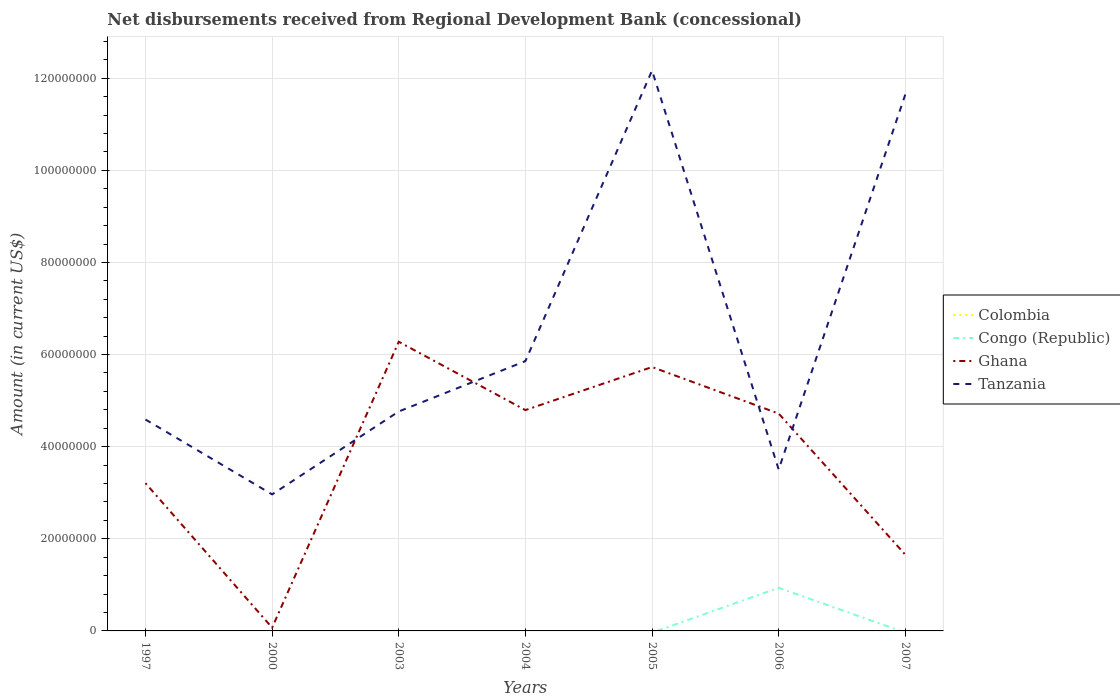Is the number of lines equal to the number of legend labels?
Keep it short and to the point. No. Across all years, what is the maximum amount of disbursements received from Regional Development Bank in Ghana?
Your answer should be very brief. 7.06e+05. What is the total amount of disbursements received from Regional Development Bank in Tanzania in the graph?
Your response must be concise. 1.08e+07. What is the difference between the highest and the second highest amount of disbursements received from Regional Development Bank in Colombia?
Provide a succinct answer. 9.60e+04. What is the difference between the highest and the lowest amount of disbursements received from Regional Development Bank in Congo (Republic)?
Ensure brevity in your answer.  1. How many years are there in the graph?
Keep it short and to the point. 7. Where does the legend appear in the graph?
Offer a terse response. Center right. How many legend labels are there?
Your response must be concise. 4. How are the legend labels stacked?
Ensure brevity in your answer.  Vertical. What is the title of the graph?
Give a very brief answer. Net disbursements received from Regional Development Bank (concessional). Does "Malaysia" appear as one of the legend labels in the graph?
Provide a short and direct response. No. What is the label or title of the Y-axis?
Provide a short and direct response. Amount (in current US$). What is the Amount (in current US$) in Colombia in 1997?
Your response must be concise. 9.60e+04. What is the Amount (in current US$) in Congo (Republic) in 1997?
Make the answer very short. 0. What is the Amount (in current US$) in Ghana in 1997?
Ensure brevity in your answer.  3.21e+07. What is the Amount (in current US$) of Tanzania in 1997?
Offer a terse response. 4.59e+07. What is the Amount (in current US$) in Colombia in 2000?
Your response must be concise. 0. What is the Amount (in current US$) in Congo (Republic) in 2000?
Provide a succinct answer. 0. What is the Amount (in current US$) in Ghana in 2000?
Offer a terse response. 7.06e+05. What is the Amount (in current US$) of Tanzania in 2000?
Provide a succinct answer. 2.96e+07. What is the Amount (in current US$) in Colombia in 2003?
Ensure brevity in your answer.  0. What is the Amount (in current US$) of Congo (Republic) in 2003?
Your answer should be compact. 0. What is the Amount (in current US$) of Ghana in 2003?
Your answer should be very brief. 6.28e+07. What is the Amount (in current US$) of Tanzania in 2003?
Provide a succinct answer. 4.76e+07. What is the Amount (in current US$) of Congo (Republic) in 2004?
Offer a very short reply. 0. What is the Amount (in current US$) in Ghana in 2004?
Your response must be concise. 4.79e+07. What is the Amount (in current US$) in Tanzania in 2004?
Your answer should be compact. 5.86e+07. What is the Amount (in current US$) of Colombia in 2005?
Give a very brief answer. 0. What is the Amount (in current US$) in Ghana in 2005?
Your answer should be compact. 5.73e+07. What is the Amount (in current US$) of Tanzania in 2005?
Give a very brief answer. 1.22e+08. What is the Amount (in current US$) of Colombia in 2006?
Offer a very short reply. 0. What is the Amount (in current US$) in Congo (Republic) in 2006?
Offer a very short reply. 9.36e+06. What is the Amount (in current US$) in Ghana in 2006?
Keep it short and to the point. 4.72e+07. What is the Amount (in current US$) in Tanzania in 2006?
Provide a short and direct response. 3.51e+07. What is the Amount (in current US$) in Colombia in 2007?
Your answer should be compact. 0. What is the Amount (in current US$) of Ghana in 2007?
Keep it short and to the point. 1.65e+07. What is the Amount (in current US$) of Tanzania in 2007?
Give a very brief answer. 1.16e+08. Across all years, what is the maximum Amount (in current US$) of Colombia?
Make the answer very short. 9.60e+04. Across all years, what is the maximum Amount (in current US$) in Congo (Republic)?
Give a very brief answer. 9.36e+06. Across all years, what is the maximum Amount (in current US$) of Ghana?
Offer a very short reply. 6.28e+07. Across all years, what is the maximum Amount (in current US$) in Tanzania?
Give a very brief answer. 1.22e+08. Across all years, what is the minimum Amount (in current US$) of Colombia?
Offer a terse response. 0. Across all years, what is the minimum Amount (in current US$) in Ghana?
Your answer should be very brief. 7.06e+05. Across all years, what is the minimum Amount (in current US$) of Tanzania?
Your answer should be very brief. 2.96e+07. What is the total Amount (in current US$) in Colombia in the graph?
Your answer should be very brief. 9.60e+04. What is the total Amount (in current US$) of Congo (Republic) in the graph?
Keep it short and to the point. 9.36e+06. What is the total Amount (in current US$) in Ghana in the graph?
Make the answer very short. 2.65e+08. What is the total Amount (in current US$) of Tanzania in the graph?
Make the answer very short. 4.55e+08. What is the difference between the Amount (in current US$) in Ghana in 1997 and that in 2000?
Your answer should be very brief. 3.14e+07. What is the difference between the Amount (in current US$) in Tanzania in 1997 and that in 2000?
Offer a terse response. 1.63e+07. What is the difference between the Amount (in current US$) of Ghana in 1997 and that in 2003?
Give a very brief answer. -3.07e+07. What is the difference between the Amount (in current US$) in Tanzania in 1997 and that in 2003?
Offer a terse response. -1.75e+06. What is the difference between the Amount (in current US$) in Ghana in 1997 and that in 2004?
Your answer should be very brief. -1.59e+07. What is the difference between the Amount (in current US$) of Tanzania in 1997 and that in 2004?
Provide a succinct answer. -1.27e+07. What is the difference between the Amount (in current US$) in Ghana in 1997 and that in 2005?
Ensure brevity in your answer.  -2.52e+07. What is the difference between the Amount (in current US$) in Tanzania in 1997 and that in 2005?
Your response must be concise. -7.58e+07. What is the difference between the Amount (in current US$) of Ghana in 1997 and that in 2006?
Your answer should be very brief. -1.51e+07. What is the difference between the Amount (in current US$) in Tanzania in 1997 and that in 2006?
Provide a short and direct response. 1.08e+07. What is the difference between the Amount (in current US$) in Ghana in 1997 and that in 2007?
Your answer should be very brief. 1.55e+07. What is the difference between the Amount (in current US$) of Tanzania in 1997 and that in 2007?
Make the answer very short. -7.06e+07. What is the difference between the Amount (in current US$) in Ghana in 2000 and that in 2003?
Your answer should be compact. -6.21e+07. What is the difference between the Amount (in current US$) in Tanzania in 2000 and that in 2003?
Make the answer very short. -1.80e+07. What is the difference between the Amount (in current US$) of Ghana in 2000 and that in 2004?
Provide a succinct answer. -4.72e+07. What is the difference between the Amount (in current US$) of Tanzania in 2000 and that in 2004?
Keep it short and to the point. -2.89e+07. What is the difference between the Amount (in current US$) in Ghana in 2000 and that in 2005?
Provide a succinct answer. -5.66e+07. What is the difference between the Amount (in current US$) in Tanzania in 2000 and that in 2005?
Provide a short and direct response. -9.20e+07. What is the difference between the Amount (in current US$) of Ghana in 2000 and that in 2006?
Your answer should be very brief. -4.65e+07. What is the difference between the Amount (in current US$) of Tanzania in 2000 and that in 2006?
Your answer should be compact. -5.41e+06. What is the difference between the Amount (in current US$) in Ghana in 2000 and that in 2007?
Give a very brief answer. -1.58e+07. What is the difference between the Amount (in current US$) of Tanzania in 2000 and that in 2007?
Provide a succinct answer. -8.68e+07. What is the difference between the Amount (in current US$) of Ghana in 2003 and that in 2004?
Make the answer very short. 1.48e+07. What is the difference between the Amount (in current US$) in Tanzania in 2003 and that in 2004?
Your response must be concise. -1.09e+07. What is the difference between the Amount (in current US$) of Ghana in 2003 and that in 2005?
Provide a short and direct response. 5.49e+06. What is the difference between the Amount (in current US$) of Tanzania in 2003 and that in 2005?
Provide a short and direct response. -7.40e+07. What is the difference between the Amount (in current US$) of Ghana in 2003 and that in 2006?
Your answer should be compact. 1.56e+07. What is the difference between the Amount (in current US$) in Tanzania in 2003 and that in 2006?
Make the answer very short. 1.26e+07. What is the difference between the Amount (in current US$) in Ghana in 2003 and that in 2007?
Your response must be concise. 4.62e+07. What is the difference between the Amount (in current US$) in Tanzania in 2003 and that in 2007?
Your response must be concise. -6.88e+07. What is the difference between the Amount (in current US$) in Ghana in 2004 and that in 2005?
Provide a short and direct response. -9.34e+06. What is the difference between the Amount (in current US$) of Tanzania in 2004 and that in 2005?
Offer a terse response. -6.31e+07. What is the difference between the Amount (in current US$) in Ghana in 2004 and that in 2006?
Offer a terse response. 7.60e+05. What is the difference between the Amount (in current US$) in Tanzania in 2004 and that in 2006?
Your answer should be very brief. 2.35e+07. What is the difference between the Amount (in current US$) in Ghana in 2004 and that in 2007?
Make the answer very short. 3.14e+07. What is the difference between the Amount (in current US$) in Tanzania in 2004 and that in 2007?
Make the answer very short. -5.79e+07. What is the difference between the Amount (in current US$) of Ghana in 2005 and that in 2006?
Offer a very short reply. 1.01e+07. What is the difference between the Amount (in current US$) in Tanzania in 2005 and that in 2006?
Your answer should be compact. 8.66e+07. What is the difference between the Amount (in current US$) of Ghana in 2005 and that in 2007?
Keep it short and to the point. 4.07e+07. What is the difference between the Amount (in current US$) of Tanzania in 2005 and that in 2007?
Make the answer very short. 5.19e+06. What is the difference between the Amount (in current US$) in Ghana in 2006 and that in 2007?
Keep it short and to the point. 3.06e+07. What is the difference between the Amount (in current US$) in Tanzania in 2006 and that in 2007?
Your answer should be very brief. -8.14e+07. What is the difference between the Amount (in current US$) in Colombia in 1997 and the Amount (in current US$) in Ghana in 2000?
Keep it short and to the point. -6.10e+05. What is the difference between the Amount (in current US$) in Colombia in 1997 and the Amount (in current US$) in Tanzania in 2000?
Keep it short and to the point. -2.95e+07. What is the difference between the Amount (in current US$) of Ghana in 1997 and the Amount (in current US$) of Tanzania in 2000?
Offer a very short reply. 2.44e+06. What is the difference between the Amount (in current US$) in Colombia in 1997 and the Amount (in current US$) in Ghana in 2003?
Provide a short and direct response. -6.27e+07. What is the difference between the Amount (in current US$) of Colombia in 1997 and the Amount (in current US$) of Tanzania in 2003?
Provide a short and direct response. -4.75e+07. What is the difference between the Amount (in current US$) in Ghana in 1997 and the Amount (in current US$) in Tanzania in 2003?
Keep it short and to the point. -1.56e+07. What is the difference between the Amount (in current US$) in Colombia in 1997 and the Amount (in current US$) in Ghana in 2004?
Give a very brief answer. -4.78e+07. What is the difference between the Amount (in current US$) in Colombia in 1997 and the Amount (in current US$) in Tanzania in 2004?
Provide a short and direct response. -5.85e+07. What is the difference between the Amount (in current US$) of Ghana in 1997 and the Amount (in current US$) of Tanzania in 2004?
Keep it short and to the point. -2.65e+07. What is the difference between the Amount (in current US$) in Colombia in 1997 and the Amount (in current US$) in Ghana in 2005?
Your answer should be compact. -5.72e+07. What is the difference between the Amount (in current US$) in Colombia in 1997 and the Amount (in current US$) in Tanzania in 2005?
Your answer should be very brief. -1.22e+08. What is the difference between the Amount (in current US$) of Ghana in 1997 and the Amount (in current US$) of Tanzania in 2005?
Provide a succinct answer. -8.96e+07. What is the difference between the Amount (in current US$) of Colombia in 1997 and the Amount (in current US$) of Congo (Republic) in 2006?
Make the answer very short. -9.26e+06. What is the difference between the Amount (in current US$) in Colombia in 1997 and the Amount (in current US$) in Ghana in 2006?
Your response must be concise. -4.71e+07. What is the difference between the Amount (in current US$) in Colombia in 1997 and the Amount (in current US$) in Tanzania in 2006?
Keep it short and to the point. -3.50e+07. What is the difference between the Amount (in current US$) of Ghana in 1997 and the Amount (in current US$) of Tanzania in 2006?
Your answer should be very brief. -2.98e+06. What is the difference between the Amount (in current US$) in Colombia in 1997 and the Amount (in current US$) in Ghana in 2007?
Give a very brief answer. -1.64e+07. What is the difference between the Amount (in current US$) in Colombia in 1997 and the Amount (in current US$) in Tanzania in 2007?
Keep it short and to the point. -1.16e+08. What is the difference between the Amount (in current US$) in Ghana in 1997 and the Amount (in current US$) in Tanzania in 2007?
Offer a terse response. -8.44e+07. What is the difference between the Amount (in current US$) in Ghana in 2000 and the Amount (in current US$) in Tanzania in 2003?
Provide a succinct answer. -4.69e+07. What is the difference between the Amount (in current US$) of Ghana in 2000 and the Amount (in current US$) of Tanzania in 2004?
Ensure brevity in your answer.  -5.79e+07. What is the difference between the Amount (in current US$) in Ghana in 2000 and the Amount (in current US$) in Tanzania in 2005?
Your answer should be compact. -1.21e+08. What is the difference between the Amount (in current US$) in Ghana in 2000 and the Amount (in current US$) in Tanzania in 2006?
Give a very brief answer. -3.43e+07. What is the difference between the Amount (in current US$) in Ghana in 2000 and the Amount (in current US$) in Tanzania in 2007?
Your answer should be very brief. -1.16e+08. What is the difference between the Amount (in current US$) of Ghana in 2003 and the Amount (in current US$) of Tanzania in 2004?
Keep it short and to the point. 4.20e+06. What is the difference between the Amount (in current US$) of Ghana in 2003 and the Amount (in current US$) of Tanzania in 2005?
Give a very brief answer. -5.89e+07. What is the difference between the Amount (in current US$) in Ghana in 2003 and the Amount (in current US$) in Tanzania in 2006?
Provide a short and direct response. 2.77e+07. What is the difference between the Amount (in current US$) of Ghana in 2003 and the Amount (in current US$) of Tanzania in 2007?
Provide a succinct answer. -5.37e+07. What is the difference between the Amount (in current US$) of Ghana in 2004 and the Amount (in current US$) of Tanzania in 2005?
Provide a short and direct response. -7.37e+07. What is the difference between the Amount (in current US$) in Ghana in 2004 and the Amount (in current US$) in Tanzania in 2006?
Keep it short and to the point. 1.29e+07. What is the difference between the Amount (in current US$) of Ghana in 2004 and the Amount (in current US$) of Tanzania in 2007?
Provide a succinct answer. -6.85e+07. What is the difference between the Amount (in current US$) of Ghana in 2005 and the Amount (in current US$) of Tanzania in 2006?
Offer a very short reply. 2.22e+07. What is the difference between the Amount (in current US$) in Ghana in 2005 and the Amount (in current US$) in Tanzania in 2007?
Offer a terse response. -5.92e+07. What is the difference between the Amount (in current US$) of Congo (Republic) in 2006 and the Amount (in current US$) of Ghana in 2007?
Your response must be concise. -7.18e+06. What is the difference between the Amount (in current US$) in Congo (Republic) in 2006 and the Amount (in current US$) in Tanzania in 2007?
Ensure brevity in your answer.  -1.07e+08. What is the difference between the Amount (in current US$) in Ghana in 2006 and the Amount (in current US$) in Tanzania in 2007?
Give a very brief answer. -6.93e+07. What is the average Amount (in current US$) in Colombia per year?
Provide a succinct answer. 1.37e+04. What is the average Amount (in current US$) in Congo (Republic) per year?
Your answer should be very brief. 1.34e+06. What is the average Amount (in current US$) of Ghana per year?
Offer a very short reply. 3.78e+07. What is the average Amount (in current US$) in Tanzania per year?
Ensure brevity in your answer.  6.50e+07. In the year 1997, what is the difference between the Amount (in current US$) of Colombia and Amount (in current US$) of Ghana?
Provide a short and direct response. -3.20e+07. In the year 1997, what is the difference between the Amount (in current US$) in Colombia and Amount (in current US$) in Tanzania?
Provide a short and direct response. -4.58e+07. In the year 1997, what is the difference between the Amount (in current US$) in Ghana and Amount (in current US$) in Tanzania?
Your answer should be compact. -1.38e+07. In the year 2000, what is the difference between the Amount (in current US$) of Ghana and Amount (in current US$) of Tanzania?
Provide a short and direct response. -2.89e+07. In the year 2003, what is the difference between the Amount (in current US$) of Ghana and Amount (in current US$) of Tanzania?
Keep it short and to the point. 1.51e+07. In the year 2004, what is the difference between the Amount (in current US$) of Ghana and Amount (in current US$) of Tanzania?
Your answer should be very brief. -1.06e+07. In the year 2005, what is the difference between the Amount (in current US$) of Ghana and Amount (in current US$) of Tanzania?
Keep it short and to the point. -6.44e+07. In the year 2006, what is the difference between the Amount (in current US$) of Congo (Republic) and Amount (in current US$) of Ghana?
Your answer should be compact. -3.78e+07. In the year 2006, what is the difference between the Amount (in current US$) of Congo (Republic) and Amount (in current US$) of Tanzania?
Give a very brief answer. -2.57e+07. In the year 2006, what is the difference between the Amount (in current US$) of Ghana and Amount (in current US$) of Tanzania?
Your answer should be very brief. 1.21e+07. In the year 2007, what is the difference between the Amount (in current US$) of Ghana and Amount (in current US$) of Tanzania?
Keep it short and to the point. -9.99e+07. What is the ratio of the Amount (in current US$) of Ghana in 1997 to that in 2000?
Provide a short and direct response. 45.43. What is the ratio of the Amount (in current US$) of Tanzania in 1997 to that in 2000?
Offer a terse response. 1.55. What is the ratio of the Amount (in current US$) in Ghana in 1997 to that in 2003?
Your answer should be very brief. 0.51. What is the ratio of the Amount (in current US$) of Tanzania in 1997 to that in 2003?
Your response must be concise. 0.96. What is the ratio of the Amount (in current US$) of Ghana in 1997 to that in 2004?
Your response must be concise. 0.67. What is the ratio of the Amount (in current US$) of Tanzania in 1997 to that in 2004?
Offer a very short reply. 0.78. What is the ratio of the Amount (in current US$) in Ghana in 1997 to that in 2005?
Your answer should be very brief. 0.56. What is the ratio of the Amount (in current US$) in Tanzania in 1997 to that in 2005?
Offer a terse response. 0.38. What is the ratio of the Amount (in current US$) of Ghana in 1997 to that in 2006?
Keep it short and to the point. 0.68. What is the ratio of the Amount (in current US$) in Tanzania in 1997 to that in 2006?
Provide a short and direct response. 1.31. What is the ratio of the Amount (in current US$) of Ghana in 1997 to that in 2007?
Provide a short and direct response. 1.94. What is the ratio of the Amount (in current US$) in Tanzania in 1997 to that in 2007?
Keep it short and to the point. 0.39. What is the ratio of the Amount (in current US$) of Ghana in 2000 to that in 2003?
Make the answer very short. 0.01. What is the ratio of the Amount (in current US$) of Tanzania in 2000 to that in 2003?
Ensure brevity in your answer.  0.62. What is the ratio of the Amount (in current US$) in Ghana in 2000 to that in 2004?
Offer a terse response. 0.01. What is the ratio of the Amount (in current US$) of Tanzania in 2000 to that in 2004?
Make the answer very short. 0.51. What is the ratio of the Amount (in current US$) in Ghana in 2000 to that in 2005?
Give a very brief answer. 0.01. What is the ratio of the Amount (in current US$) of Tanzania in 2000 to that in 2005?
Your answer should be compact. 0.24. What is the ratio of the Amount (in current US$) in Ghana in 2000 to that in 2006?
Offer a terse response. 0.01. What is the ratio of the Amount (in current US$) in Tanzania in 2000 to that in 2006?
Offer a very short reply. 0.85. What is the ratio of the Amount (in current US$) of Ghana in 2000 to that in 2007?
Offer a terse response. 0.04. What is the ratio of the Amount (in current US$) of Tanzania in 2000 to that in 2007?
Ensure brevity in your answer.  0.25. What is the ratio of the Amount (in current US$) of Ghana in 2003 to that in 2004?
Your answer should be very brief. 1.31. What is the ratio of the Amount (in current US$) in Tanzania in 2003 to that in 2004?
Give a very brief answer. 0.81. What is the ratio of the Amount (in current US$) in Ghana in 2003 to that in 2005?
Make the answer very short. 1.1. What is the ratio of the Amount (in current US$) in Tanzania in 2003 to that in 2005?
Give a very brief answer. 0.39. What is the ratio of the Amount (in current US$) of Ghana in 2003 to that in 2006?
Your answer should be very brief. 1.33. What is the ratio of the Amount (in current US$) in Tanzania in 2003 to that in 2006?
Keep it short and to the point. 1.36. What is the ratio of the Amount (in current US$) of Ghana in 2003 to that in 2007?
Your response must be concise. 3.79. What is the ratio of the Amount (in current US$) of Tanzania in 2003 to that in 2007?
Your answer should be very brief. 0.41. What is the ratio of the Amount (in current US$) in Ghana in 2004 to that in 2005?
Provide a succinct answer. 0.84. What is the ratio of the Amount (in current US$) in Tanzania in 2004 to that in 2005?
Give a very brief answer. 0.48. What is the ratio of the Amount (in current US$) of Ghana in 2004 to that in 2006?
Your answer should be compact. 1.02. What is the ratio of the Amount (in current US$) in Tanzania in 2004 to that in 2006?
Provide a short and direct response. 1.67. What is the ratio of the Amount (in current US$) of Ghana in 2004 to that in 2007?
Make the answer very short. 2.9. What is the ratio of the Amount (in current US$) in Tanzania in 2004 to that in 2007?
Provide a short and direct response. 0.5. What is the ratio of the Amount (in current US$) in Ghana in 2005 to that in 2006?
Your response must be concise. 1.21. What is the ratio of the Amount (in current US$) in Tanzania in 2005 to that in 2006?
Offer a very short reply. 3.47. What is the ratio of the Amount (in current US$) in Ghana in 2005 to that in 2007?
Offer a terse response. 3.46. What is the ratio of the Amount (in current US$) in Tanzania in 2005 to that in 2007?
Ensure brevity in your answer.  1.04. What is the ratio of the Amount (in current US$) in Ghana in 2006 to that in 2007?
Keep it short and to the point. 2.85. What is the ratio of the Amount (in current US$) of Tanzania in 2006 to that in 2007?
Your answer should be compact. 0.3. What is the difference between the highest and the second highest Amount (in current US$) of Ghana?
Provide a succinct answer. 5.49e+06. What is the difference between the highest and the second highest Amount (in current US$) of Tanzania?
Your response must be concise. 5.19e+06. What is the difference between the highest and the lowest Amount (in current US$) of Colombia?
Provide a succinct answer. 9.60e+04. What is the difference between the highest and the lowest Amount (in current US$) in Congo (Republic)?
Offer a very short reply. 9.36e+06. What is the difference between the highest and the lowest Amount (in current US$) of Ghana?
Provide a succinct answer. 6.21e+07. What is the difference between the highest and the lowest Amount (in current US$) in Tanzania?
Provide a short and direct response. 9.20e+07. 